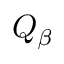Convert formula to latex. <formula><loc_0><loc_0><loc_500><loc_500>Q _ { \beta }</formula> 